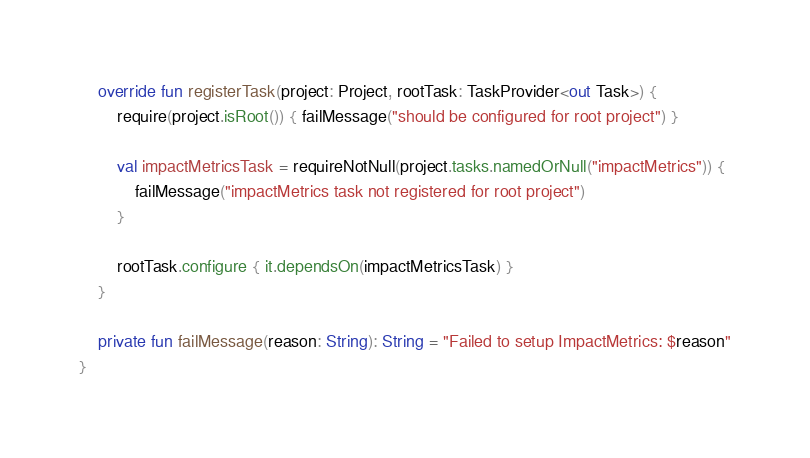<code> <loc_0><loc_0><loc_500><loc_500><_Kotlin_>    override fun registerTask(project: Project, rootTask: TaskProvider<out Task>) {
        require(project.isRoot()) { failMessage("should be configured for root project") }

        val impactMetricsTask = requireNotNull(project.tasks.namedOrNull("impactMetrics")) {
            failMessage("impactMetrics task not registered for root project")
        }

        rootTask.configure { it.dependsOn(impactMetricsTask) }
    }

    private fun failMessage(reason: String): String = "Failed to setup ImpactMetrics: $reason"
}
</code> 